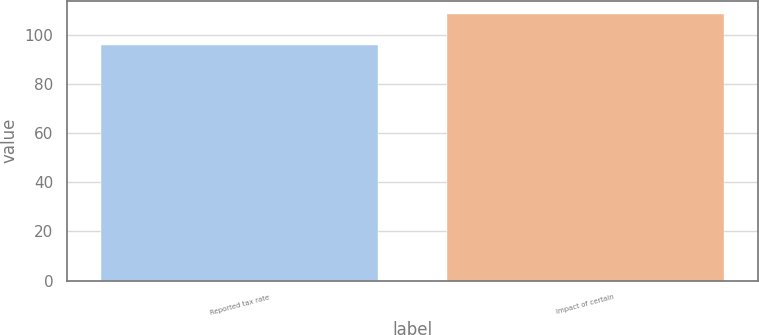Convert chart to OTSL. <chart><loc_0><loc_0><loc_500><loc_500><bar_chart><fcel>Reported tax rate<fcel>Impact of certain<nl><fcel>95.9<fcel>108.3<nl></chart> 